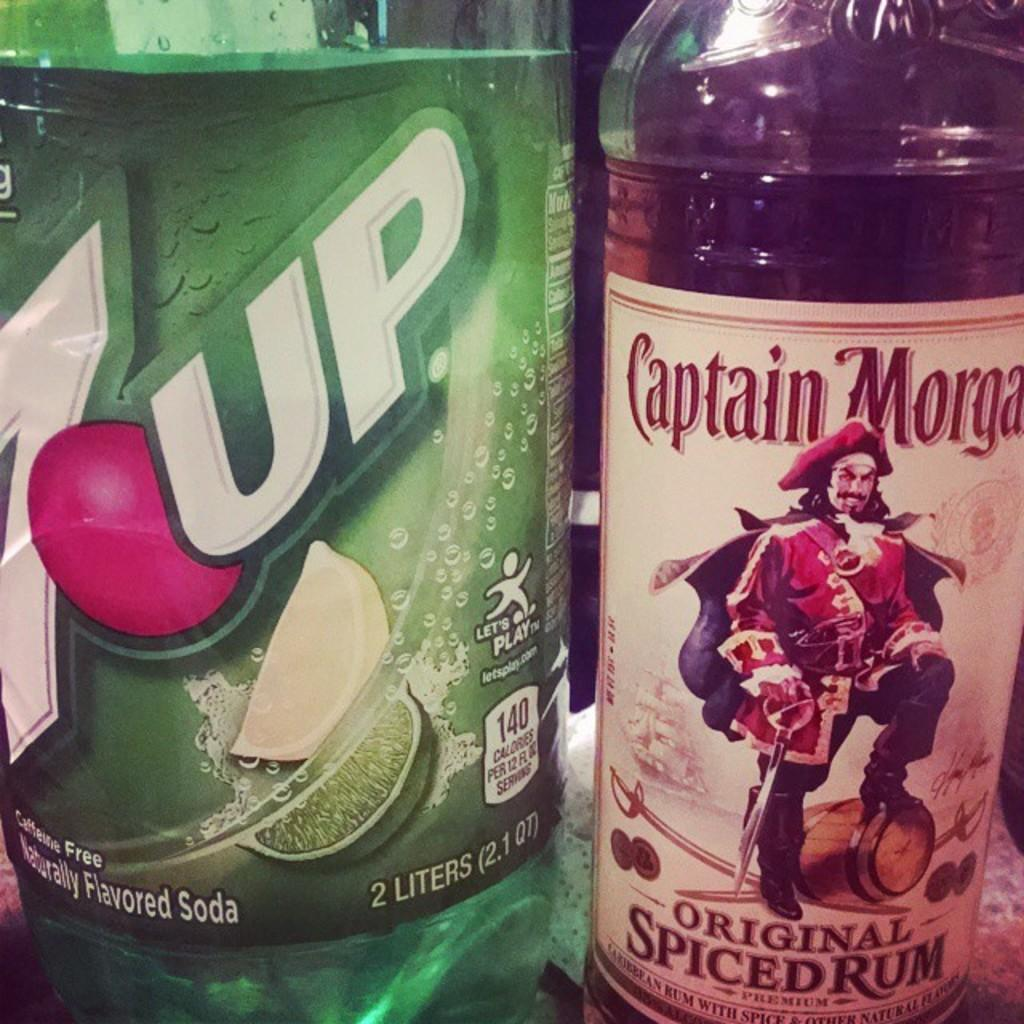<image>
Summarize the visual content of the image. A bottle of Captain Morgan has a pirate on the label. 